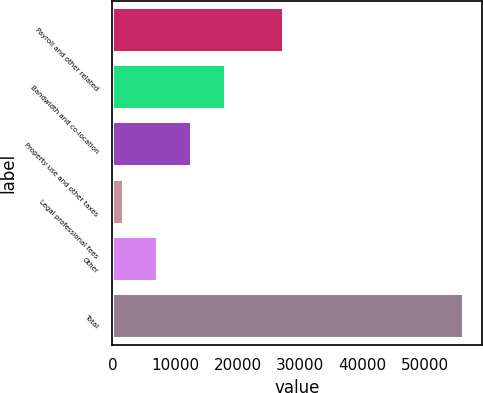Convert chart to OTSL. <chart><loc_0><loc_0><loc_500><loc_500><bar_chart><fcel>Payroll and other related<fcel>Bandwidth and co-location<fcel>Property use and other taxes<fcel>Legal professional fees<fcel>Other<fcel>Total<nl><fcel>27381<fcel>18116.6<fcel>12671.4<fcel>1781<fcel>7226.2<fcel>56233<nl></chart> 